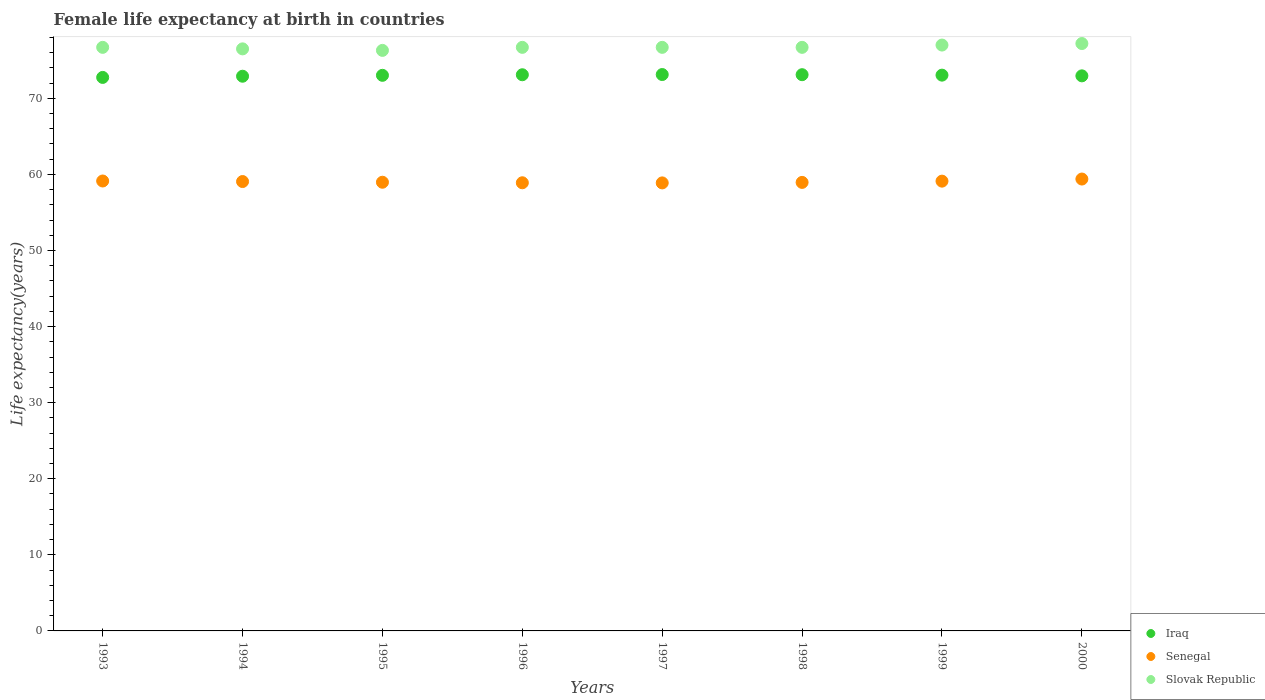How many different coloured dotlines are there?
Offer a very short reply. 3. Across all years, what is the maximum female life expectancy at birth in Slovak Republic?
Your answer should be very brief. 77.2. Across all years, what is the minimum female life expectancy at birth in Slovak Republic?
Give a very brief answer. 76.3. In which year was the female life expectancy at birth in Senegal maximum?
Make the answer very short. 2000. In which year was the female life expectancy at birth in Slovak Republic minimum?
Provide a short and direct response. 1995. What is the total female life expectancy at birth in Slovak Republic in the graph?
Ensure brevity in your answer.  613.8. What is the difference between the female life expectancy at birth in Iraq in 1999 and that in 2000?
Offer a terse response. 0.09. What is the difference between the female life expectancy at birth in Iraq in 1998 and the female life expectancy at birth in Senegal in 1996?
Ensure brevity in your answer.  14.21. What is the average female life expectancy at birth in Iraq per year?
Give a very brief answer. 73. In the year 1993, what is the difference between the female life expectancy at birth in Slovak Republic and female life expectancy at birth in Senegal?
Give a very brief answer. 17.57. What is the ratio of the female life expectancy at birth in Slovak Republic in 1994 to that in 1995?
Your answer should be compact. 1. Is the female life expectancy at birth in Iraq in 1994 less than that in 1997?
Give a very brief answer. Yes. What is the difference between the highest and the second highest female life expectancy at birth in Senegal?
Make the answer very short. 0.26. What is the difference between the highest and the lowest female life expectancy at birth in Iraq?
Your answer should be compact. 0.38. Is it the case that in every year, the sum of the female life expectancy at birth in Iraq and female life expectancy at birth in Slovak Republic  is greater than the female life expectancy at birth in Senegal?
Your answer should be very brief. Yes. Is the female life expectancy at birth in Iraq strictly greater than the female life expectancy at birth in Senegal over the years?
Make the answer very short. Yes. How many dotlines are there?
Ensure brevity in your answer.  3. Are the values on the major ticks of Y-axis written in scientific E-notation?
Offer a terse response. No. Does the graph contain any zero values?
Your answer should be very brief. No. Does the graph contain grids?
Offer a terse response. No. Where does the legend appear in the graph?
Offer a very short reply. Bottom right. How many legend labels are there?
Ensure brevity in your answer.  3. How are the legend labels stacked?
Keep it short and to the point. Vertical. What is the title of the graph?
Ensure brevity in your answer.  Female life expectancy at birth in countries. Does "Mongolia" appear as one of the legend labels in the graph?
Your answer should be compact. No. What is the label or title of the Y-axis?
Provide a short and direct response. Life expectancy(years). What is the Life expectancy(years) of Iraq in 1993?
Your response must be concise. 72.75. What is the Life expectancy(years) of Senegal in 1993?
Offer a terse response. 59.13. What is the Life expectancy(years) of Slovak Republic in 1993?
Your answer should be compact. 76.7. What is the Life expectancy(years) in Iraq in 1994?
Keep it short and to the point. 72.91. What is the Life expectancy(years) of Senegal in 1994?
Your answer should be very brief. 59.06. What is the Life expectancy(years) in Slovak Republic in 1994?
Offer a very short reply. 76.5. What is the Life expectancy(years) of Iraq in 1995?
Provide a short and direct response. 73.02. What is the Life expectancy(years) in Senegal in 1995?
Make the answer very short. 58.97. What is the Life expectancy(years) of Slovak Republic in 1995?
Your response must be concise. 76.3. What is the Life expectancy(years) of Iraq in 1996?
Provide a succinct answer. 73.1. What is the Life expectancy(years) of Senegal in 1996?
Your response must be concise. 58.9. What is the Life expectancy(years) in Slovak Republic in 1996?
Ensure brevity in your answer.  76.7. What is the Life expectancy(years) of Iraq in 1997?
Offer a terse response. 73.13. What is the Life expectancy(years) in Senegal in 1997?
Offer a terse response. 58.88. What is the Life expectancy(years) in Slovak Republic in 1997?
Your answer should be very brief. 76.7. What is the Life expectancy(years) of Iraq in 1998?
Your answer should be very brief. 73.11. What is the Life expectancy(years) of Senegal in 1998?
Offer a very short reply. 58.95. What is the Life expectancy(years) of Slovak Republic in 1998?
Offer a very short reply. 76.7. What is the Life expectancy(years) in Iraq in 1999?
Make the answer very short. 73.05. What is the Life expectancy(years) of Senegal in 1999?
Give a very brief answer. 59.12. What is the Life expectancy(years) of Slovak Republic in 1999?
Provide a short and direct response. 77. What is the Life expectancy(years) in Iraq in 2000?
Ensure brevity in your answer.  72.95. What is the Life expectancy(years) of Senegal in 2000?
Provide a short and direct response. 59.39. What is the Life expectancy(years) of Slovak Republic in 2000?
Your answer should be compact. 77.2. Across all years, what is the maximum Life expectancy(years) of Iraq?
Offer a terse response. 73.13. Across all years, what is the maximum Life expectancy(years) in Senegal?
Provide a succinct answer. 59.39. Across all years, what is the maximum Life expectancy(years) of Slovak Republic?
Provide a short and direct response. 77.2. Across all years, what is the minimum Life expectancy(years) of Iraq?
Your response must be concise. 72.75. Across all years, what is the minimum Life expectancy(years) in Senegal?
Your response must be concise. 58.88. Across all years, what is the minimum Life expectancy(years) in Slovak Republic?
Make the answer very short. 76.3. What is the total Life expectancy(years) of Iraq in the graph?
Provide a succinct answer. 584.01. What is the total Life expectancy(years) in Senegal in the graph?
Your answer should be very brief. 472.41. What is the total Life expectancy(years) of Slovak Republic in the graph?
Provide a short and direct response. 613.8. What is the difference between the Life expectancy(years) in Iraq in 1993 and that in 1994?
Your answer should be compact. -0.16. What is the difference between the Life expectancy(years) of Senegal in 1993 and that in 1994?
Offer a terse response. 0.07. What is the difference between the Life expectancy(years) of Slovak Republic in 1993 and that in 1994?
Offer a terse response. 0.2. What is the difference between the Life expectancy(years) in Iraq in 1993 and that in 1995?
Provide a succinct answer. -0.28. What is the difference between the Life expectancy(years) in Senegal in 1993 and that in 1995?
Provide a short and direct response. 0.16. What is the difference between the Life expectancy(years) of Slovak Republic in 1993 and that in 1995?
Keep it short and to the point. 0.4. What is the difference between the Life expectancy(years) in Iraq in 1993 and that in 1996?
Make the answer very short. -0.35. What is the difference between the Life expectancy(years) of Senegal in 1993 and that in 1996?
Offer a very short reply. 0.23. What is the difference between the Life expectancy(years) in Slovak Republic in 1993 and that in 1996?
Your response must be concise. 0. What is the difference between the Life expectancy(years) of Iraq in 1993 and that in 1997?
Your answer should be compact. -0.38. What is the difference between the Life expectancy(years) in Senegal in 1993 and that in 1997?
Provide a short and direct response. 0.25. What is the difference between the Life expectancy(years) of Iraq in 1993 and that in 1998?
Provide a short and direct response. -0.36. What is the difference between the Life expectancy(years) in Senegal in 1993 and that in 1998?
Your answer should be very brief. 0.18. What is the difference between the Life expectancy(years) in Slovak Republic in 1993 and that in 1998?
Your response must be concise. 0. What is the difference between the Life expectancy(years) in Iraq in 1993 and that in 1999?
Ensure brevity in your answer.  -0.3. What is the difference between the Life expectancy(years) in Senegal in 1993 and that in 1999?
Your answer should be compact. 0.02. What is the difference between the Life expectancy(years) in Slovak Republic in 1993 and that in 1999?
Offer a very short reply. -0.3. What is the difference between the Life expectancy(years) of Iraq in 1993 and that in 2000?
Your answer should be very brief. -0.21. What is the difference between the Life expectancy(years) of Senegal in 1993 and that in 2000?
Keep it short and to the point. -0.26. What is the difference between the Life expectancy(years) of Iraq in 1994 and that in 1995?
Offer a very short reply. -0.12. What is the difference between the Life expectancy(years) of Senegal in 1994 and that in 1995?
Ensure brevity in your answer.  0.09. What is the difference between the Life expectancy(years) of Iraq in 1994 and that in 1996?
Your answer should be compact. -0.19. What is the difference between the Life expectancy(years) in Senegal in 1994 and that in 1996?
Provide a short and direct response. 0.16. What is the difference between the Life expectancy(years) of Iraq in 1994 and that in 1997?
Offer a terse response. -0.22. What is the difference between the Life expectancy(years) in Senegal in 1994 and that in 1997?
Give a very brief answer. 0.18. What is the difference between the Life expectancy(years) of Iraq in 1994 and that in 1998?
Offer a very short reply. -0.2. What is the difference between the Life expectancy(years) of Senegal in 1994 and that in 1998?
Provide a succinct answer. 0.11. What is the difference between the Life expectancy(years) in Iraq in 1994 and that in 1999?
Your response must be concise. -0.14. What is the difference between the Life expectancy(years) in Senegal in 1994 and that in 1999?
Provide a short and direct response. -0.05. What is the difference between the Life expectancy(years) in Iraq in 1994 and that in 2000?
Keep it short and to the point. -0.05. What is the difference between the Life expectancy(years) of Senegal in 1994 and that in 2000?
Provide a succinct answer. -0.33. What is the difference between the Life expectancy(years) of Iraq in 1995 and that in 1996?
Keep it short and to the point. -0.07. What is the difference between the Life expectancy(years) in Senegal in 1995 and that in 1996?
Make the answer very short. 0.07. What is the difference between the Life expectancy(years) of Slovak Republic in 1995 and that in 1996?
Your answer should be very brief. -0.4. What is the difference between the Life expectancy(years) in Iraq in 1995 and that in 1997?
Offer a terse response. -0.1. What is the difference between the Life expectancy(years) of Senegal in 1995 and that in 1997?
Give a very brief answer. 0.09. What is the difference between the Life expectancy(years) in Slovak Republic in 1995 and that in 1997?
Make the answer very short. -0.4. What is the difference between the Life expectancy(years) in Iraq in 1995 and that in 1998?
Provide a short and direct response. -0.08. What is the difference between the Life expectancy(years) of Senegal in 1995 and that in 1998?
Provide a succinct answer. 0.02. What is the difference between the Life expectancy(years) of Iraq in 1995 and that in 1999?
Make the answer very short. -0.02. What is the difference between the Life expectancy(years) in Senegal in 1995 and that in 1999?
Offer a very short reply. -0.14. What is the difference between the Life expectancy(years) of Iraq in 1995 and that in 2000?
Your answer should be very brief. 0.07. What is the difference between the Life expectancy(years) of Senegal in 1995 and that in 2000?
Ensure brevity in your answer.  -0.42. What is the difference between the Life expectancy(years) in Iraq in 1996 and that in 1997?
Ensure brevity in your answer.  -0.03. What is the difference between the Life expectancy(years) in Senegal in 1996 and that in 1997?
Keep it short and to the point. 0.02. What is the difference between the Life expectancy(years) of Iraq in 1996 and that in 1998?
Ensure brevity in your answer.  -0.01. What is the difference between the Life expectancy(years) in Senegal in 1996 and that in 1998?
Offer a very short reply. -0.05. What is the difference between the Life expectancy(years) in Slovak Republic in 1996 and that in 1998?
Keep it short and to the point. 0. What is the difference between the Life expectancy(years) in Iraq in 1996 and that in 1999?
Provide a short and direct response. 0.05. What is the difference between the Life expectancy(years) in Senegal in 1996 and that in 1999?
Give a very brief answer. -0.21. What is the difference between the Life expectancy(years) in Slovak Republic in 1996 and that in 1999?
Your answer should be compact. -0.3. What is the difference between the Life expectancy(years) of Iraq in 1996 and that in 2000?
Offer a very short reply. 0.14. What is the difference between the Life expectancy(years) of Senegal in 1996 and that in 2000?
Provide a succinct answer. -0.49. What is the difference between the Life expectancy(years) of Slovak Republic in 1996 and that in 2000?
Your answer should be compact. -0.5. What is the difference between the Life expectancy(years) of Iraq in 1997 and that in 1998?
Offer a very short reply. 0.02. What is the difference between the Life expectancy(years) of Senegal in 1997 and that in 1998?
Provide a short and direct response. -0.07. What is the difference between the Life expectancy(years) in Slovak Republic in 1997 and that in 1998?
Provide a succinct answer. 0. What is the difference between the Life expectancy(years) in Iraq in 1997 and that in 1999?
Provide a succinct answer. 0.08. What is the difference between the Life expectancy(years) of Senegal in 1997 and that in 1999?
Keep it short and to the point. -0.23. What is the difference between the Life expectancy(years) of Iraq in 1997 and that in 2000?
Your answer should be very brief. 0.17. What is the difference between the Life expectancy(years) of Senegal in 1997 and that in 2000?
Offer a very short reply. -0.51. What is the difference between the Life expectancy(years) in Iraq in 1998 and that in 1999?
Your response must be concise. 0.06. What is the difference between the Life expectancy(years) of Senegal in 1998 and that in 1999?
Offer a very short reply. -0.17. What is the difference between the Life expectancy(years) in Slovak Republic in 1998 and that in 1999?
Make the answer very short. -0.3. What is the difference between the Life expectancy(years) of Iraq in 1998 and that in 2000?
Your response must be concise. 0.15. What is the difference between the Life expectancy(years) of Senegal in 1998 and that in 2000?
Offer a terse response. -0.44. What is the difference between the Life expectancy(years) in Iraq in 1999 and that in 2000?
Keep it short and to the point. 0.09. What is the difference between the Life expectancy(years) in Senegal in 1999 and that in 2000?
Provide a succinct answer. -0.28. What is the difference between the Life expectancy(years) in Iraq in 1993 and the Life expectancy(years) in Senegal in 1994?
Offer a very short reply. 13.69. What is the difference between the Life expectancy(years) of Iraq in 1993 and the Life expectancy(years) of Slovak Republic in 1994?
Keep it short and to the point. -3.75. What is the difference between the Life expectancy(years) of Senegal in 1993 and the Life expectancy(years) of Slovak Republic in 1994?
Offer a terse response. -17.37. What is the difference between the Life expectancy(years) in Iraq in 1993 and the Life expectancy(years) in Senegal in 1995?
Ensure brevity in your answer.  13.78. What is the difference between the Life expectancy(years) of Iraq in 1993 and the Life expectancy(years) of Slovak Republic in 1995?
Ensure brevity in your answer.  -3.55. What is the difference between the Life expectancy(years) in Senegal in 1993 and the Life expectancy(years) in Slovak Republic in 1995?
Offer a very short reply. -17.17. What is the difference between the Life expectancy(years) in Iraq in 1993 and the Life expectancy(years) in Senegal in 1996?
Provide a short and direct response. 13.85. What is the difference between the Life expectancy(years) in Iraq in 1993 and the Life expectancy(years) in Slovak Republic in 1996?
Make the answer very short. -3.95. What is the difference between the Life expectancy(years) in Senegal in 1993 and the Life expectancy(years) in Slovak Republic in 1996?
Offer a very short reply. -17.57. What is the difference between the Life expectancy(years) in Iraq in 1993 and the Life expectancy(years) in Senegal in 1997?
Provide a succinct answer. 13.86. What is the difference between the Life expectancy(years) of Iraq in 1993 and the Life expectancy(years) of Slovak Republic in 1997?
Provide a succinct answer. -3.95. What is the difference between the Life expectancy(years) of Senegal in 1993 and the Life expectancy(years) of Slovak Republic in 1997?
Provide a short and direct response. -17.57. What is the difference between the Life expectancy(years) in Iraq in 1993 and the Life expectancy(years) in Senegal in 1998?
Give a very brief answer. 13.8. What is the difference between the Life expectancy(years) in Iraq in 1993 and the Life expectancy(years) in Slovak Republic in 1998?
Offer a terse response. -3.95. What is the difference between the Life expectancy(years) in Senegal in 1993 and the Life expectancy(years) in Slovak Republic in 1998?
Your response must be concise. -17.57. What is the difference between the Life expectancy(years) of Iraq in 1993 and the Life expectancy(years) of Senegal in 1999?
Offer a terse response. 13.63. What is the difference between the Life expectancy(years) in Iraq in 1993 and the Life expectancy(years) in Slovak Republic in 1999?
Your answer should be very brief. -4.25. What is the difference between the Life expectancy(years) of Senegal in 1993 and the Life expectancy(years) of Slovak Republic in 1999?
Your answer should be compact. -17.87. What is the difference between the Life expectancy(years) in Iraq in 1993 and the Life expectancy(years) in Senegal in 2000?
Provide a succinct answer. 13.36. What is the difference between the Life expectancy(years) in Iraq in 1993 and the Life expectancy(years) in Slovak Republic in 2000?
Offer a very short reply. -4.45. What is the difference between the Life expectancy(years) of Senegal in 1993 and the Life expectancy(years) of Slovak Republic in 2000?
Offer a terse response. -18.07. What is the difference between the Life expectancy(years) in Iraq in 1994 and the Life expectancy(years) in Senegal in 1995?
Make the answer very short. 13.93. What is the difference between the Life expectancy(years) of Iraq in 1994 and the Life expectancy(years) of Slovak Republic in 1995?
Make the answer very short. -3.4. What is the difference between the Life expectancy(years) of Senegal in 1994 and the Life expectancy(years) of Slovak Republic in 1995?
Provide a succinct answer. -17.24. What is the difference between the Life expectancy(years) in Iraq in 1994 and the Life expectancy(years) in Senegal in 1996?
Offer a terse response. 14. What is the difference between the Life expectancy(years) in Iraq in 1994 and the Life expectancy(years) in Slovak Republic in 1996?
Your answer should be compact. -3.79. What is the difference between the Life expectancy(years) of Senegal in 1994 and the Life expectancy(years) of Slovak Republic in 1996?
Provide a succinct answer. -17.64. What is the difference between the Life expectancy(years) in Iraq in 1994 and the Life expectancy(years) in Senegal in 1997?
Give a very brief answer. 14.02. What is the difference between the Life expectancy(years) in Iraq in 1994 and the Life expectancy(years) in Slovak Republic in 1997?
Keep it short and to the point. -3.79. What is the difference between the Life expectancy(years) of Senegal in 1994 and the Life expectancy(years) of Slovak Republic in 1997?
Your answer should be very brief. -17.64. What is the difference between the Life expectancy(years) in Iraq in 1994 and the Life expectancy(years) in Senegal in 1998?
Your answer should be compact. 13.96. What is the difference between the Life expectancy(years) of Iraq in 1994 and the Life expectancy(years) of Slovak Republic in 1998?
Ensure brevity in your answer.  -3.79. What is the difference between the Life expectancy(years) in Senegal in 1994 and the Life expectancy(years) in Slovak Republic in 1998?
Ensure brevity in your answer.  -17.64. What is the difference between the Life expectancy(years) of Iraq in 1994 and the Life expectancy(years) of Senegal in 1999?
Keep it short and to the point. 13.79. What is the difference between the Life expectancy(years) of Iraq in 1994 and the Life expectancy(years) of Slovak Republic in 1999?
Keep it short and to the point. -4.09. What is the difference between the Life expectancy(years) in Senegal in 1994 and the Life expectancy(years) in Slovak Republic in 1999?
Provide a succinct answer. -17.94. What is the difference between the Life expectancy(years) of Iraq in 1994 and the Life expectancy(years) of Senegal in 2000?
Keep it short and to the point. 13.51. What is the difference between the Life expectancy(years) of Iraq in 1994 and the Life expectancy(years) of Slovak Republic in 2000?
Your answer should be compact. -4.29. What is the difference between the Life expectancy(years) in Senegal in 1994 and the Life expectancy(years) in Slovak Republic in 2000?
Give a very brief answer. -18.14. What is the difference between the Life expectancy(years) in Iraq in 1995 and the Life expectancy(years) in Senegal in 1996?
Your response must be concise. 14.12. What is the difference between the Life expectancy(years) of Iraq in 1995 and the Life expectancy(years) of Slovak Republic in 1996?
Ensure brevity in your answer.  -3.68. What is the difference between the Life expectancy(years) in Senegal in 1995 and the Life expectancy(years) in Slovak Republic in 1996?
Keep it short and to the point. -17.73. What is the difference between the Life expectancy(years) in Iraq in 1995 and the Life expectancy(years) in Senegal in 1997?
Ensure brevity in your answer.  14.14. What is the difference between the Life expectancy(years) in Iraq in 1995 and the Life expectancy(years) in Slovak Republic in 1997?
Ensure brevity in your answer.  -3.68. What is the difference between the Life expectancy(years) in Senegal in 1995 and the Life expectancy(years) in Slovak Republic in 1997?
Make the answer very short. -17.73. What is the difference between the Life expectancy(years) in Iraq in 1995 and the Life expectancy(years) in Senegal in 1998?
Offer a very short reply. 14.07. What is the difference between the Life expectancy(years) in Iraq in 1995 and the Life expectancy(years) in Slovak Republic in 1998?
Offer a terse response. -3.68. What is the difference between the Life expectancy(years) in Senegal in 1995 and the Life expectancy(years) in Slovak Republic in 1998?
Your answer should be very brief. -17.73. What is the difference between the Life expectancy(years) in Iraq in 1995 and the Life expectancy(years) in Senegal in 1999?
Your answer should be compact. 13.91. What is the difference between the Life expectancy(years) of Iraq in 1995 and the Life expectancy(years) of Slovak Republic in 1999?
Offer a terse response. -3.98. What is the difference between the Life expectancy(years) in Senegal in 1995 and the Life expectancy(years) in Slovak Republic in 1999?
Your answer should be compact. -18.03. What is the difference between the Life expectancy(years) in Iraq in 1995 and the Life expectancy(years) in Senegal in 2000?
Keep it short and to the point. 13.63. What is the difference between the Life expectancy(years) of Iraq in 1995 and the Life expectancy(years) of Slovak Republic in 2000?
Make the answer very short. -4.18. What is the difference between the Life expectancy(years) of Senegal in 1995 and the Life expectancy(years) of Slovak Republic in 2000?
Your answer should be compact. -18.23. What is the difference between the Life expectancy(years) of Iraq in 1996 and the Life expectancy(years) of Senegal in 1997?
Your response must be concise. 14.21. What is the difference between the Life expectancy(years) of Iraq in 1996 and the Life expectancy(years) of Slovak Republic in 1997?
Your response must be concise. -3.6. What is the difference between the Life expectancy(years) in Senegal in 1996 and the Life expectancy(years) in Slovak Republic in 1997?
Your response must be concise. -17.8. What is the difference between the Life expectancy(years) of Iraq in 1996 and the Life expectancy(years) of Senegal in 1998?
Give a very brief answer. 14.15. What is the difference between the Life expectancy(years) in Iraq in 1996 and the Life expectancy(years) in Slovak Republic in 1998?
Your answer should be compact. -3.6. What is the difference between the Life expectancy(years) of Senegal in 1996 and the Life expectancy(years) of Slovak Republic in 1998?
Keep it short and to the point. -17.8. What is the difference between the Life expectancy(years) in Iraq in 1996 and the Life expectancy(years) in Senegal in 1999?
Offer a very short reply. 13.98. What is the difference between the Life expectancy(years) of Iraq in 1996 and the Life expectancy(years) of Slovak Republic in 1999?
Your answer should be very brief. -3.9. What is the difference between the Life expectancy(years) in Senegal in 1996 and the Life expectancy(years) in Slovak Republic in 1999?
Keep it short and to the point. -18.1. What is the difference between the Life expectancy(years) in Iraq in 1996 and the Life expectancy(years) in Senegal in 2000?
Make the answer very short. 13.71. What is the difference between the Life expectancy(years) in Iraq in 1996 and the Life expectancy(years) in Slovak Republic in 2000?
Ensure brevity in your answer.  -4.1. What is the difference between the Life expectancy(years) in Senegal in 1996 and the Life expectancy(years) in Slovak Republic in 2000?
Your answer should be very brief. -18.3. What is the difference between the Life expectancy(years) of Iraq in 1997 and the Life expectancy(years) of Senegal in 1998?
Offer a very short reply. 14.18. What is the difference between the Life expectancy(years) in Iraq in 1997 and the Life expectancy(years) in Slovak Republic in 1998?
Offer a terse response. -3.57. What is the difference between the Life expectancy(years) in Senegal in 1997 and the Life expectancy(years) in Slovak Republic in 1998?
Make the answer very short. -17.82. What is the difference between the Life expectancy(years) in Iraq in 1997 and the Life expectancy(years) in Senegal in 1999?
Provide a succinct answer. 14.01. What is the difference between the Life expectancy(years) in Iraq in 1997 and the Life expectancy(years) in Slovak Republic in 1999?
Your answer should be compact. -3.87. What is the difference between the Life expectancy(years) of Senegal in 1997 and the Life expectancy(years) of Slovak Republic in 1999?
Give a very brief answer. -18.12. What is the difference between the Life expectancy(years) of Iraq in 1997 and the Life expectancy(years) of Senegal in 2000?
Your answer should be very brief. 13.73. What is the difference between the Life expectancy(years) of Iraq in 1997 and the Life expectancy(years) of Slovak Republic in 2000?
Make the answer very short. -4.07. What is the difference between the Life expectancy(years) in Senegal in 1997 and the Life expectancy(years) in Slovak Republic in 2000?
Give a very brief answer. -18.32. What is the difference between the Life expectancy(years) in Iraq in 1998 and the Life expectancy(years) in Senegal in 1999?
Keep it short and to the point. 13.99. What is the difference between the Life expectancy(years) of Iraq in 1998 and the Life expectancy(years) of Slovak Republic in 1999?
Give a very brief answer. -3.89. What is the difference between the Life expectancy(years) of Senegal in 1998 and the Life expectancy(years) of Slovak Republic in 1999?
Make the answer very short. -18.05. What is the difference between the Life expectancy(years) of Iraq in 1998 and the Life expectancy(years) of Senegal in 2000?
Provide a short and direct response. 13.71. What is the difference between the Life expectancy(years) in Iraq in 1998 and the Life expectancy(years) in Slovak Republic in 2000?
Your answer should be very brief. -4.09. What is the difference between the Life expectancy(years) of Senegal in 1998 and the Life expectancy(years) of Slovak Republic in 2000?
Keep it short and to the point. -18.25. What is the difference between the Life expectancy(years) in Iraq in 1999 and the Life expectancy(years) in Senegal in 2000?
Offer a terse response. 13.66. What is the difference between the Life expectancy(years) of Iraq in 1999 and the Life expectancy(years) of Slovak Republic in 2000?
Offer a terse response. -4.15. What is the difference between the Life expectancy(years) in Senegal in 1999 and the Life expectancy(years) in Slovak Republic in 2000?
Your answer should be compact. -18.09. What is the average Life expectancy(years) of Iraq per year?
Give a very brief answer. 73. What is the average Life expectancy(years) of Senegal per year?
Make the answer very short. 59.05. What is the average Life expectancy(years) of Slovak Republic per year?
Make the answer very short. 76.72. In the year 1993, what is the difference between the Life expectancy(years) of Iraq and Life expectancy(years) of Senegal?
Make the answer very short. 13.61. In the year 1993, what is the difference between the Life expectancy(years) in Iraq and Life expectancy(years) in Slovak Republic?
Your response must be concise. -3.95. In the year 1993, what is the difference between the Life expectancy(years) in Senegal and Life expectancy(years) in Slovak Republic?
Provide a short and direct response. -17.57. In the year 1994, what is the difference between the Life expectancy(years) in Iraq and Life expectancy(years) in Senegal?
Provide a short and direct response. 13.84. In the year 1994, what is the difference between the Life expectancy(years) of Iraq and Life expectancy(years) of Slovak Republic?
Your answer should be very brief. -3.6. In the year 1994, what is the difference between the Life expectancy(years) in Senegal and Life expectancy(years) in Slovak Republic?
Provide a succinct answer. -17.44. In the year 1995, what is the difference between the Life expectancy(years) in Iraq and Life expectancy(years) in Senegal?
Keep it short and to the point. 14.05. In the year 1995, what is the difference between the Life expectancy(years) in Iraq and Life expectancy(years) in Slovak Republic?
Provide a short and direct response. -3.28. In the year 1995, what is the difference between the Life expectancy(years) in Senegal and Life expectancy(years) in Slovak Republic?
Make the answer very short. -17.33. In the year 1996, what is the difference between the Life expectancy(years) in Iraq and Life expectancy(years) in Senegal?
Make the answer very short. 14.2. In the year 1996, what is the difference between the Life expectancy(years) in Iraq and Life expectancy(years) in Slovak Republic?
Ensure brevity in your answer.  -3.6. In the year 1996, what is the difference between the Life expectancy(years) of Senegal and Life expectancy(years) of Slovak Republic?
Provide a short and direct response. -17.8. In the year 1997, what is the difference between the Life expectancy(years) of Iraq and Life expectancy(years) of Senegal?
Your response must be concise. 14.24. In the year 1997, what is the difference between the Life expectancy(years) in Iraq and Life expectancy(years) in Slovak Republic?
Your answer should be very brief. -3.57. In the year 1997, what is the difference between the Life expectancy(years) of Senegal and Life expectancy(years) of Slovak Republic?
Keep it short and to the point. -17.82. In the year 1998, what is the difference between the Life expectancy(years) of Iraq and Life expectancy(years) of Senegal?
Provide a short and direct response. 14.16. In the year 1998, what is the difference between the Life expectancy(years) of Iraq and Life expectancy(years) of Slovak Republic?
Your answer should be very brief. -3.59. In the year 1998, what is the difference between the Life expectancy(years) in Senegal and Life expectancy(years) in Slovak Republic?
Your answer should be very brief. -17.75. In the year 1999, what is the difference between the Life expectancy(years) in Iraq and Life expectancy(years) in Senegal?
Provide a short and direct response. 13.93. In the year 1999, what is the difference between the Life expectancy(years) of Iraq and Life expectancy(years) of Slovak Republic?
Keep it short and to the point. -3.95. In the year 1999, what is the difference between the Life expectancy(years) in Senegal and Life expectancy(years) in Slovak Republic?
Your answer should be very brief. -17.89. In the year 2000, what is the difference between the Life expectancy(years) in Iraq and Life expectancy(years) in Senegal?
Give a very brief answer. 13.56. In the year 2000, what is the difference between the Life expectancy(years) of Iraq and Life expectancy(years) of Slovak Republic?
Your answer should be very brief. -4.25. In the year 2000, what is the difference between the Life expectancy(years) of Senegal and Life expectancy(years) of Slovak Republic?
Provide a succinct answer. -17.81. What is the ratio of the Life expectancy(years) in Slovak Republic in 1993 to that in 1995?
Give a very brief answer. 1.01. What is the ratio of the Life expectancy(years) in Iraq in 1993 to that in 1996?
Give a very brief answer. 1. What is the ratio of the Life expectancy(years) of Senegal in 1993 to that in 1996?
Offer a very short reply. 1. What is the ratio of the Life expectancy(years) of Senegal in 1993 to that in 1997?
Ensure brevity in your answer.  1. What is the ratio of the Life expectancy(years) of Slovak Republic in 1993 to that in 1997?
Your answer should be very brief. 1. What is the ratio of the Life expectancy(years) in Iraq in 1993 to that in 1998?
Provide a succinct answer. 1. What is the ratio of the Life expectancy(years) in Iraq in 1993 to that in 1999?
Provide a short and direct response. 1. What is the ratio of the Life expectancy(years) in Senegal in 1993 to that in 1999?
Keep it short and to the point. 1. What is the ratio of the Life expectancy(years) of Slovak Republic in 1993 to that in 1999?
Provide a short and direct response. 1. What is the ratio of the Life expectancy(years) of Senegal in 1993 to that in 2000?
Give a very brief answer. 1. What is the ratio of the Life expectancy(years) in Senegal in 1994 to that in 1995?
Give a very brief answer. 1. What is the ratio of the Life expectancy(years) in Iraq in 1994 to that in 1996?
Your answer should be very brief. 1. What is the ratio of the Life expectancy(years) in Iraq in 1994 to that in 1997?
Make the answer very short. 1. What is the ratio of the Life expectancy(years) of Senegal in 1994 to that in 1997?
Keep it short and to the point. 1. What is the ratio of the Life expectancy(years) in Senegal in 1994 to that in 1998?
Provide a succinct answer. 1. What is the ratio of the Life expectancy(years) in Slovak Republic in 1994 to that in 1998?
Give a very brief answer. 1. What is the ratio of the Life expectancy(years) in Senegal in 1994 to that in 1999?
Offer a very short reply. 1. What is the ratio of the Life expectancy(years) in Iraq in 1994 to that in 2000?
Provide a short and direct response. 1. What is the ratio of the Life expectancy(years) in Senegal in 1994 to that in 2000?
Your answer should be very brief. 0.99. What is the ratio of the Life expectancy(years) of Slovak Republic in 1994 to that in 2000?
Make the answer very short. 0.99. What is the ratio of the Life expectancy(years) in Slovak Republic in 1995 to that in 1996?
Keep it short and to the point. 0.99. What is the ratio of the Life expectancy(years) in Iraq in 1995 to that in 1997?
Your answer should be compact. 1. What is the ratio of the Life expectancy(years) in Slovak Republic in 1995 to that in 1997?
Provide a short and direct response. 0.99. What is the ratio of the Life expectancy(years) of Iraq in 1995 to that in 1999?
Keep it short and to the point. 1. What is the ratio of the Life expectancy(years) in Senegal in 1995 to that in 1999?
Ensure brevity in your answer.  1. What is the ratio of the Life expectancy(years) in Slovak Republic in 1995 to that in 1999?
Your answer should be very brief. 0.99. What is the ratio of the Life expectancy(years) of Slovak Republic in 1995 to that in 2000?
Offer a very short reply. 0.99. What is the ratio of the Life expectancy(years) of Senegal in 1996 to that in 1997?
Your answer should be very brief. 1. What is the ratio of the Life expectancy(years) of Iraq in 1996 to that in 1999?
Make the answer very short. 1. What is the ratio of the Life expectancy(years) of Senegal in 1996 to that in 1999?
Ensure brevity in your answer.  1. What is the ratio of the Life expectancy(years) in Slovak Republic in 1996 to that in 1999?
Give a very brief answer. 1. What is the ratio of the Life expectancy(years) of Iraq in 1996 to that in 2000?
Provide a short and direct response. 1. What is the ratio of the Life expectancy(years) of Slovak Republic in 1996 to that in 2000?
Make the answer very short. 0.99. What is the ratio of the Life expectancy(years) in Slovak Republic in 1997 to that in 1998?
Your answer should be compact. 1. What is the ratio of the Life expectancy(years) of Iraq in 1997 to that in 1999?
Keep it short and to the point. 1. What is the ratio of the Life expectancy(years) in Senegal in 1997 to that in 1999?
Offer a terse response. 1. What is the ratio of the Life expectancy(years) in Slovak Republic in 1997 to that in 2000?
Give a very brief answer. 0.99. What is the ratio of the Life expectancy(years) in Senegal in 1998 to that in 1999?
Ensure brevity in your answer.  1. What is the ratio of the Life expectancy(years) in Slovak Republic in 1998 to that in 1999?
Provide a succinct answer. 1. What is the ratio of the Life expectancy(years) of Iraq in 1998 to that in 2000?
Make the answer very short. 1. What is the ratio of the Life expectancy(years) of Slovak Republic in 1998 to that in 2000?
Your answer should be compact. 0.99. What is the ratio of the Life expectancy(years) in Iraq in 1999 to that in 2000?
Provide a succinct answer. 1. What is the ratio of the Life expectancy(years) of Senegal in 1999 to that in 2000?
Offer a very short reply. 1. What is the ratio of the Life expectancy(years) in Slovak Republic in 1999 to that in 2000?
Your answer should be compact. 1. What is the difference between the highest and the second highest Life expectancy(years) of Senegal?
Make the answer very short. 0.26. What is the difference between the highest and the lowest Life expectancy(years) in Iraq?
Your answer should be very brief. 0.38. What is the difference between the highest and the lowest Life expectancy(years) of Senegal?
Give a very brief answer. 0.51. What is the difference between the highest and the lowest Life expectancy(years) in Slovak Republic?
Ensure brevity in your answer.  0.9. 